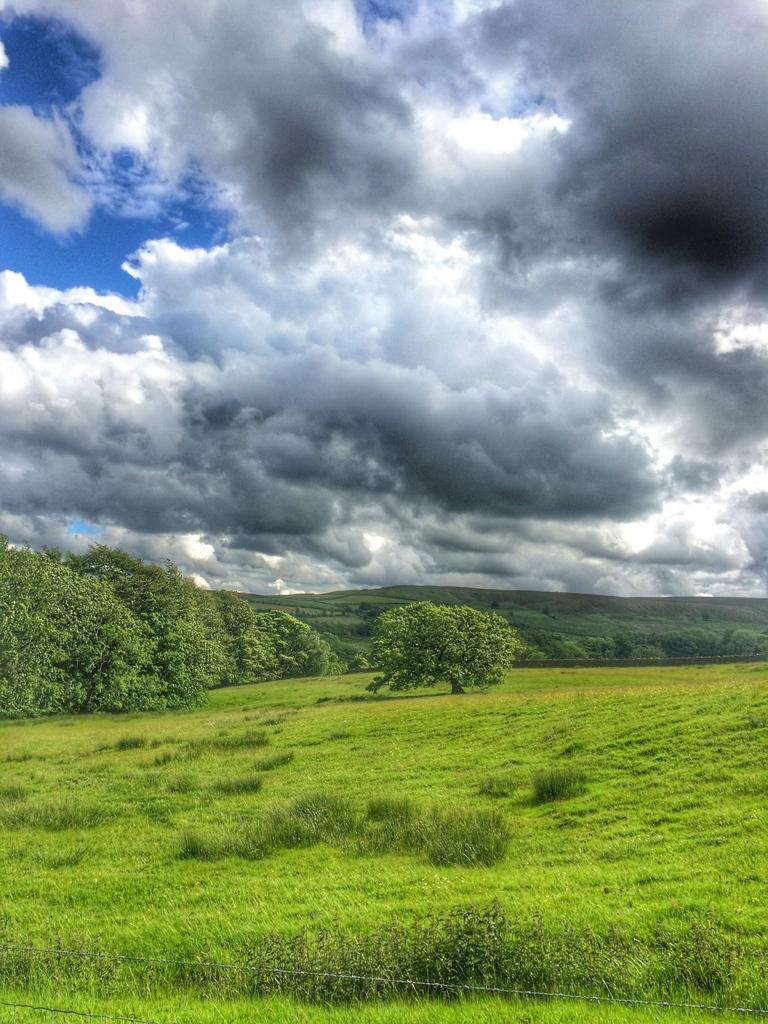What type of vegetation can be seen in the image? There is grass in the image. What else can be seen in the image besides grass? There are trees in the image. What is visible in the background of the image? The sky is visible in the image. What can be observed in the sky? Clouds are present in the sky. What type of root can be seen growing from the clouds in the image? There is no root visible in the image, and the clouds are not connected to the ground. What argument is being presented by the trees in the image? The trees are not capable of presenting arguments, as they are inanimate objects. 